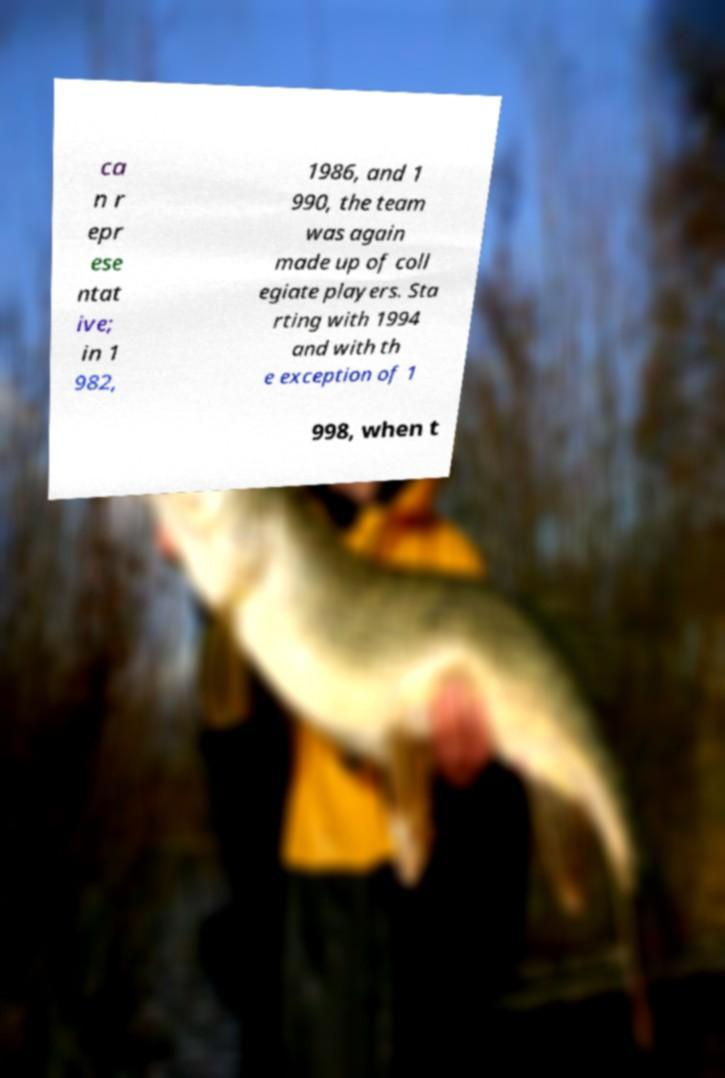Could you extract and type out the text from this image? ca n r epr ese ntat ive; in 1 982, 1986, and 1 990, the team was again made up of coll egiate players. Sta rting with 1994 and with th e exception of 1 998, when t 